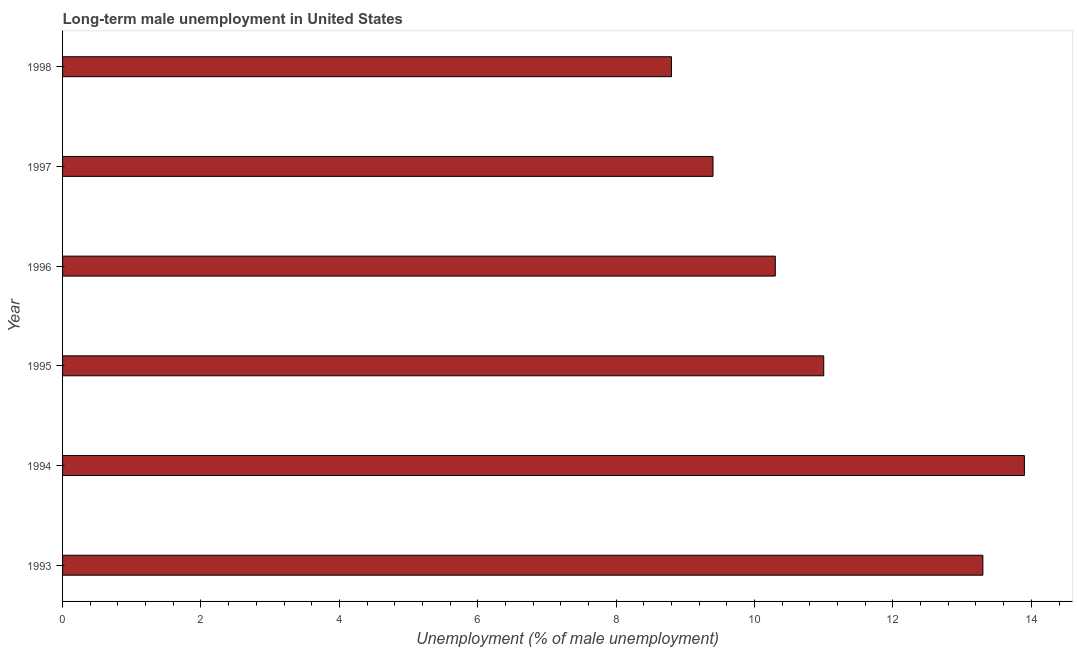Does the graph contain any zero values?
Your answer should be very brief. No. Does the graph contain grids?
Keep it short and to the point. No. What is the title of the graph?
Provide a succinct answer. Long-term male unemployment in United States. What is the label or title of the X-axis?
Ensure brevity in your answer.  Unemployment (% of male unemployment). What is the long-term male unemployment in 1994?
Give a very brief answer. 13.9. Across all years, what is the maximum long-term male unemployment?
Provide a short and direct response. 13.9. Across all years, what is the minimum long-term male unemployment?
Ensure brevity in your answer.  8.8. In which year was the long-term male unemployment minimum?
Provide a short and direct response. 1998. What is the sum of the long-term male unemployment?
Ensure brevity in your answer.  66.7. What is the difference between the long-term male unemployment in 1995 and 1996?
Your response must be concise. 0.7. What is the average long-term male unemployment per year?
Your response must be concise. 11.12. What is the median long-term male unemployment?
Provide a succinct answer. 10.65. In how many years, is the long-term male unemployment greater than 7.2 %?
Provide a short and direct response. 6. Do a majority of the years between 1998 and 1994 (inclusive) have long-term male unemployment greater than 6.4 %?
Keep it short and to the point. Yes. Is the long-term male unemployment in 1993 less than that in 1998?
Offer a terse response. No. What is the difference between the highest and the lowest long-term male unemployment?
Make the answer very short. 5.1. In how many years, is the long-term male unemployment greater than the average long-term male unemployment taken over all years?
Your answer should be very brief. 2. How many bars are there?
Ensure brevity in your answer.  6. Are all the bars in the graph horizontal?
Make the answer very short. Yes. Are the values on the major ticks of X-axis written in scientific E-notation?
Provide a short and direct response. No. What is the Unemployment (% of male unemployment) in 1993?
Make the answer very short. 13.3. What is the Unemployment (% of male unemployment) of 1994?
Make the answer very short. 13.9. What is the Unemployment (% of male unemployment) of 1996?
Offer a very short reply. 10.3. What is the Unemployment (% of male unemployment) of 1997?
Your answer should be very brief. 9.4. What is the Unemployment (% of male unemployment) in 1998?
Your answer should be very brief. 8.8. What is the difference between the Unemployment (% of male unemployment) in 1993 and 1995?
Provide a short and direct response. 2.3. What is the difference between the Unemployment (% of male unemployment) in 1993 and 1996?
Keep it short and to the point. 3. What is the difference between the Unemployment (% of male unemployment) in 1993 and 1997?
Make the answer very short. 3.9. What is the difference between the Unemployment (% of male unemployment) in 1994 and 1995?
Keep it short and to the point. 2.9. What is the difference between the Unemployment (% of male unemployment) in 1994 and 1996?
Provide a short and direct response. 3.6. What is the difference between the Unemployment (% of male unemployment) in 1995 and 1997?
Offer a very short reply. 1.6. What is the difference between the Unemployment (% of male unemployment) in 1996 and 1998?
Ensure brevity in your answer.  1.5. What is the ratio of the Unemployment (% of male unemployment) in 1993 to that in 1994?
Make the answer very short. 0.96. What is the ratio of the Unemployment (% of male unemployment) in 1993 to that in 1995?
Give a very brief answer. 1.21. What is the ratio of the Unemployment (% of male unemployment) in 1993 to that in 1996?
Ensure brevity in your answer.  1.29. What is the ratio of the Unemployment (% of male unemployment) in 1993 to that in 1997?
Give a very brief answer. 1.42. What is the ratio of the Unemployment (% of male unemployment) in 1993 to that in 1998?
Your response must be concise. 1.51. What is the ratio of the Unemployment (% of male unemployment) in 1994 to that in 1995?
Offer a terse response. 1.26. What is the ratio of the Unemployment (% of male unemployment) in 1994 to that in 1996?
Give a very brief answer. 1.35. What is the ratio of the Unemployment (% of male unemployment) in 1994 to that in 1997?
Give a very brief answer. 1.48. What is the ratio of the Unemployment (% of male unemployment) in 1994 to that in 1998?
Your answer should be compact. 1.58. What is the ratio of the Unemployment (% of male unemployment) in 1995 to that in 1996?
Ensure brevity in your answer.  1.07. What is the ratio of the Unemployment (% of male unemployment) in 1995 to that in 1997?
Offer a terse response. 1.17. What is the ratio of the Unemployment (% of male unemployment) in 1995 to that in 1998?
Ensure brevity in your answer.  1.25. What is the ratio of the Unemployment (% of male unemployment) in 1996 to that in 1997?
Provide a short and direct response. 1.1. What is the ratio of the Unemployment (% of male unemployment) in 1996 to that in 1998?
Provide a succinct answer. 1.17. What is the ratio of the Unemployment (% of male unemployment) in 1997 to that in 1998?
Keep it short and to the point. 1.07. 